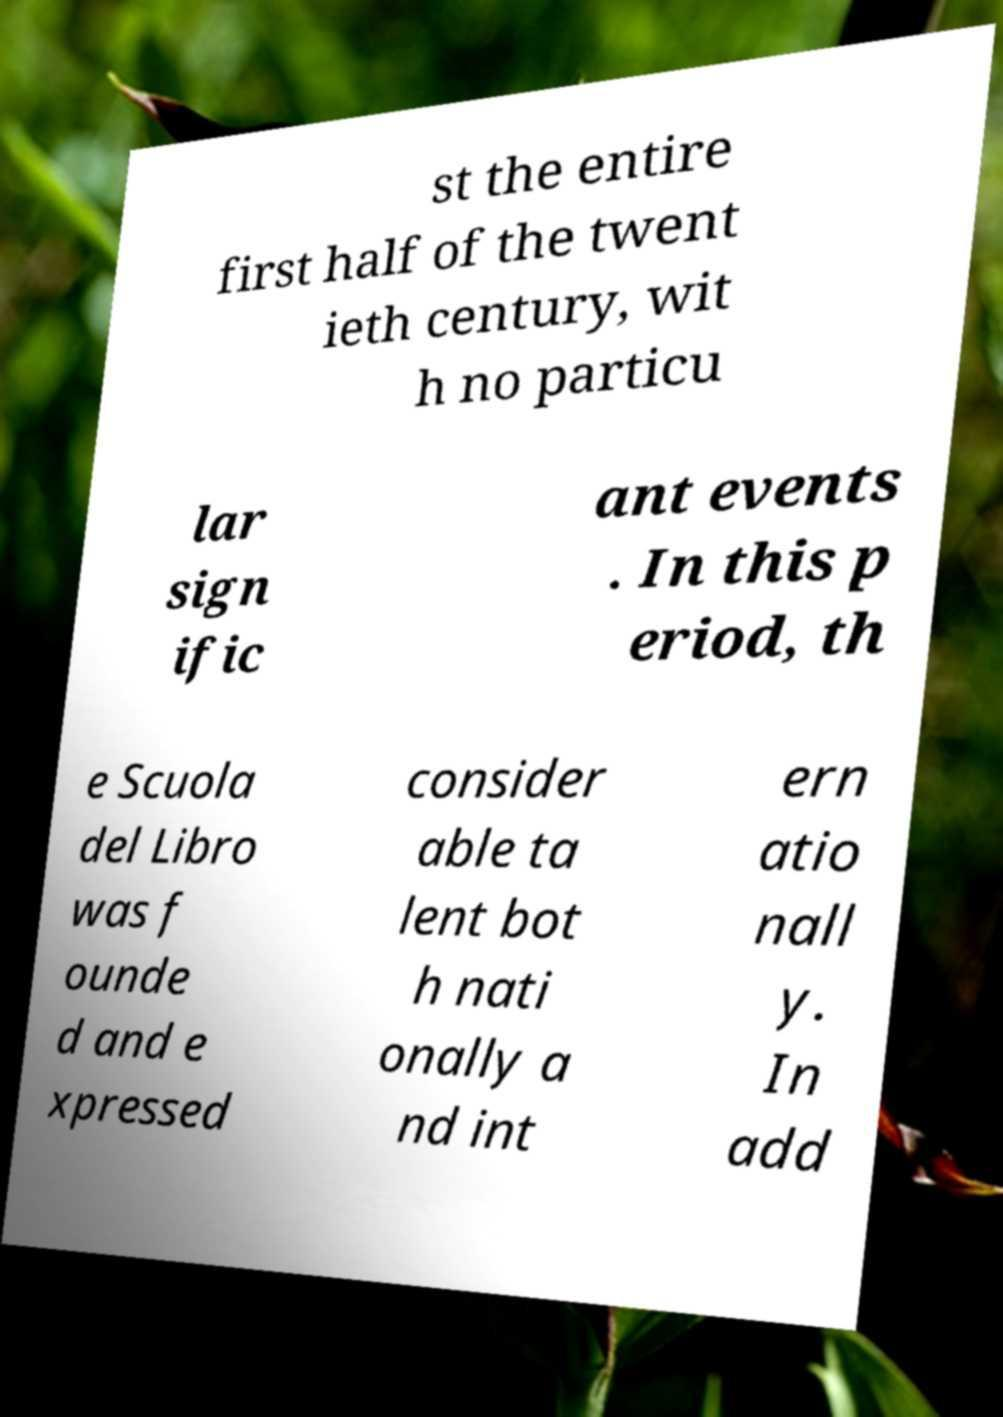Could you assist in decoding the text presented in this image and type it out clearly? st the entire first half of the twent ieth century, wit h no particu lar sign ific ant events . In this p eriod, th e Scuola del Libro was f ounde d and e xpressed consider able ta lent bot h nati onally a nd int ern atio nall y. In add 